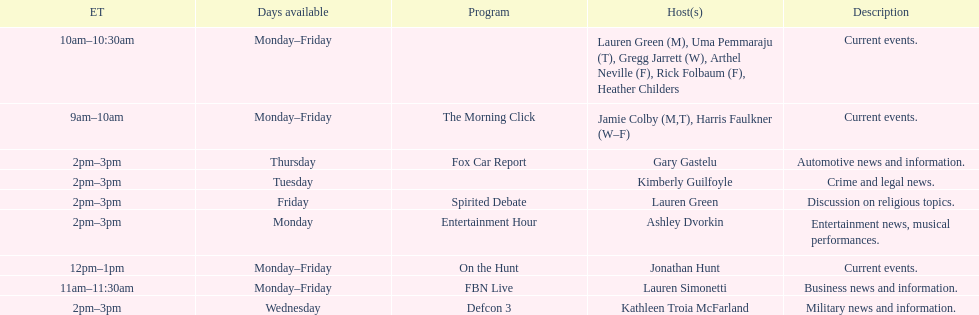How long does the show defcon 3 last? 1 hour. 